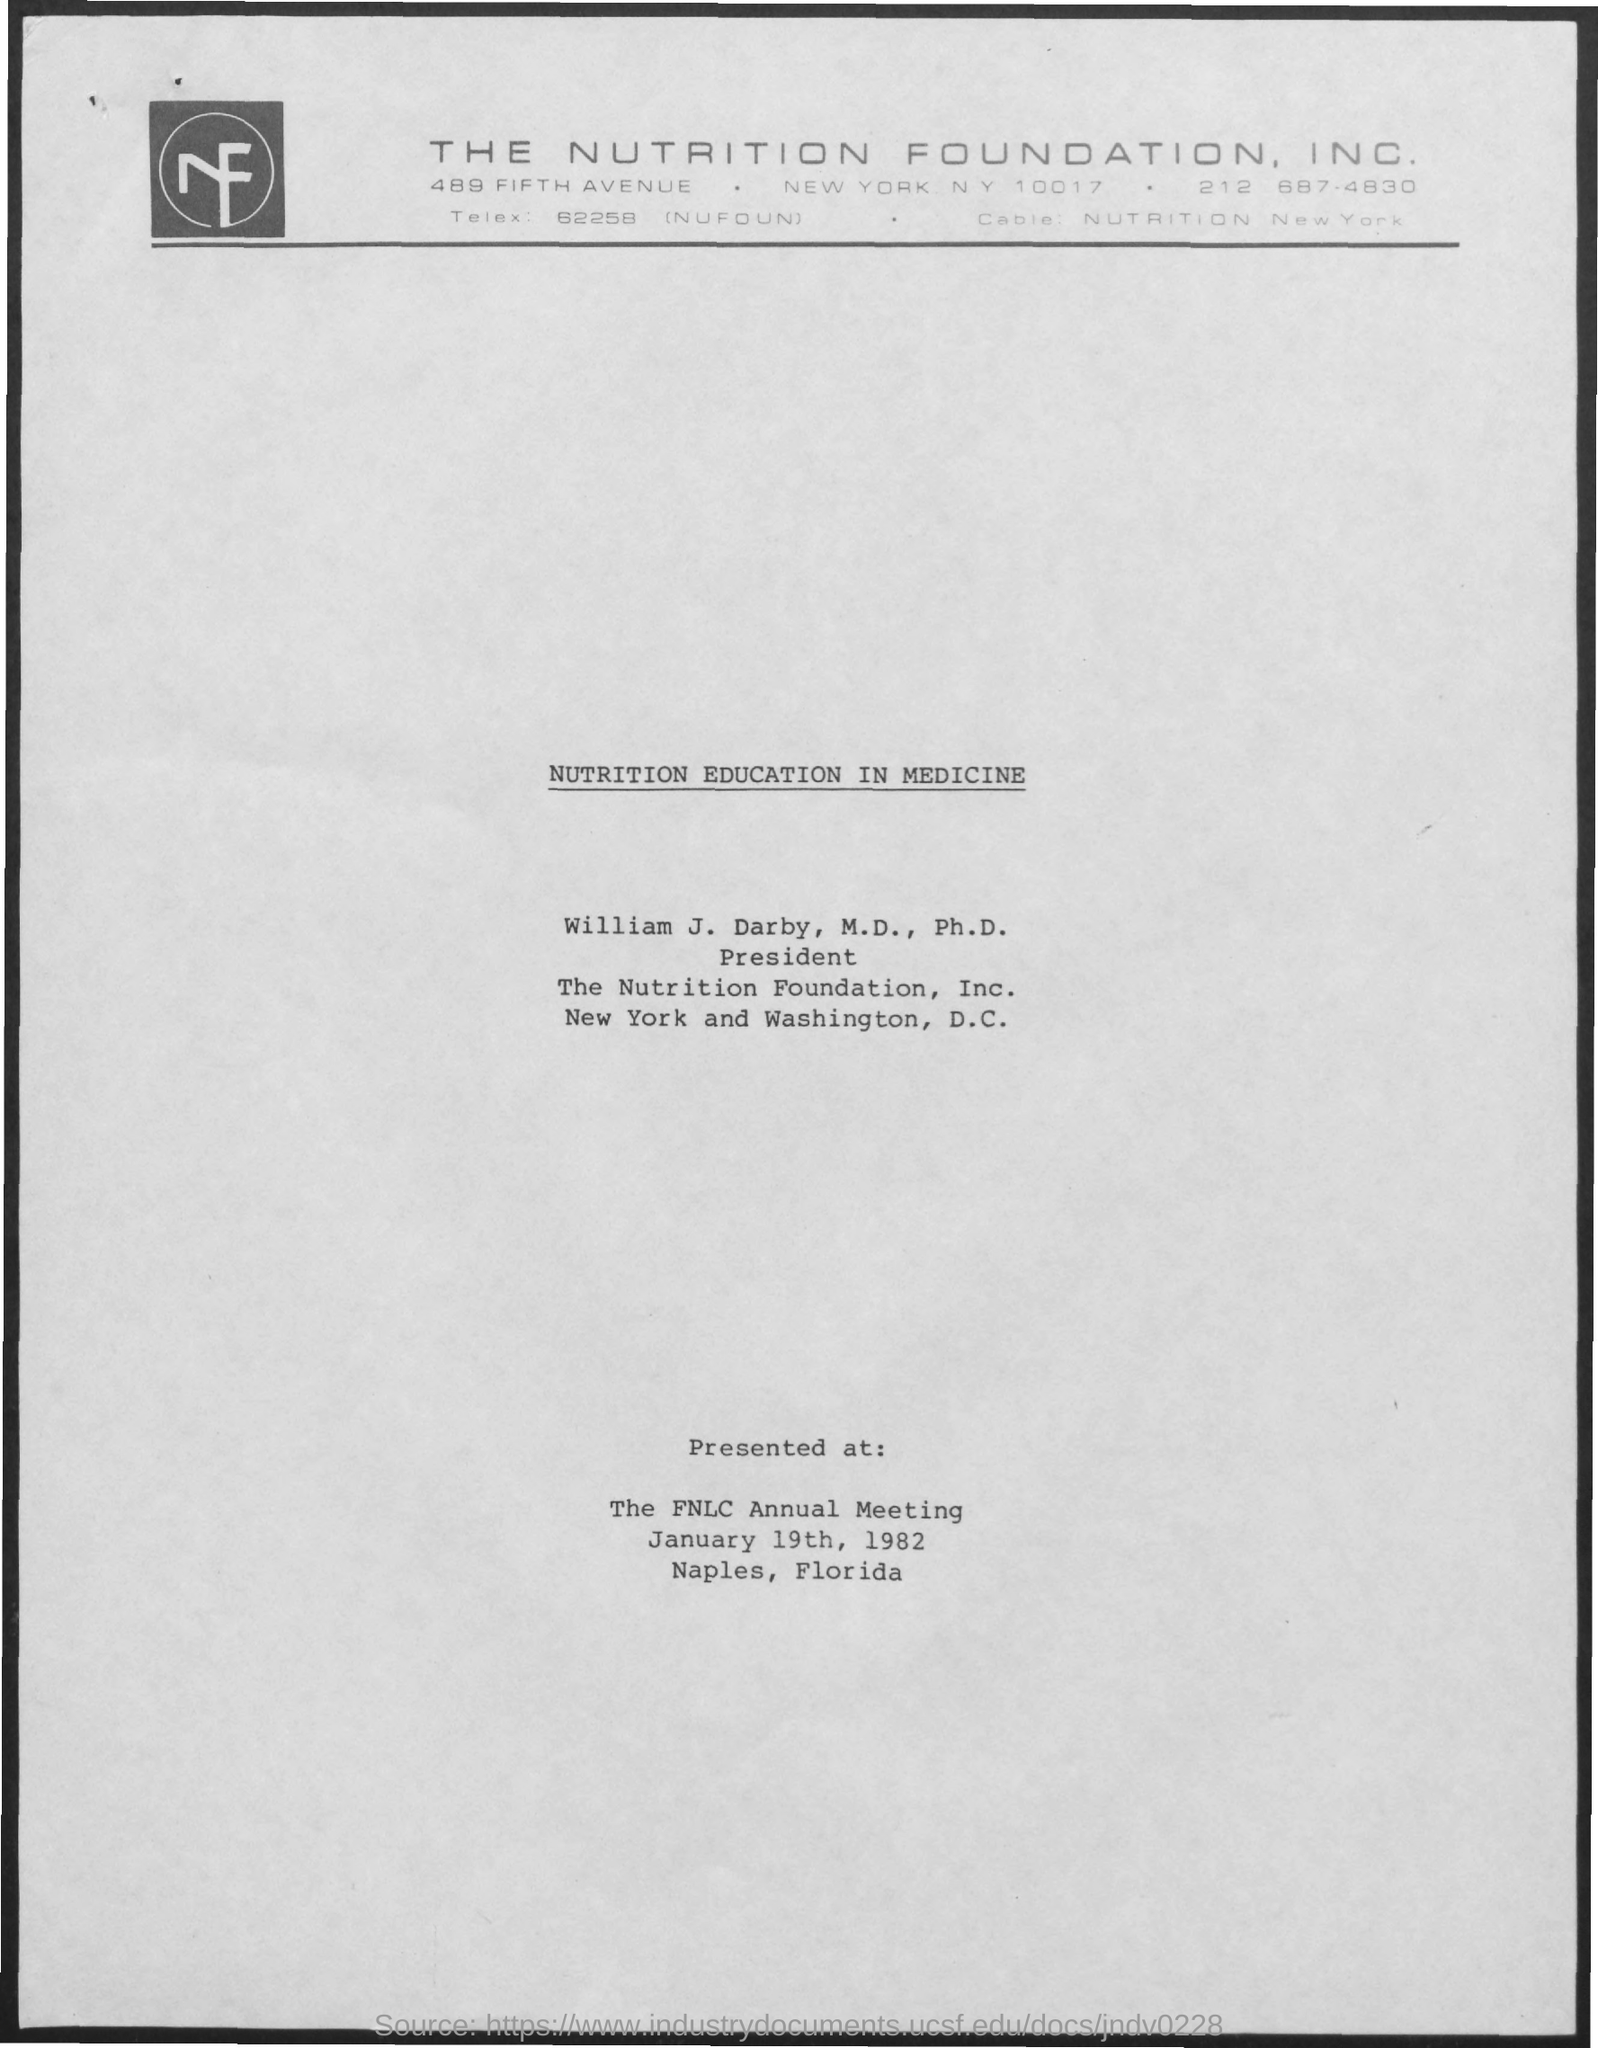Which foundation is mentioned?
Provide a short and direct response. THE NUTRITION FOUNDATION, INC. Who is the president of The Nutrition Foundation, Inc.?
Offer a very short reply. William J. Darby, M,D., Ph.D. Where was NUTRITION EDUCATION IN MEDICINE presented?
Ensure brevity in your answer.  The FNLC Annual Meeting. When was the meeting held?
Give a very brief answer. January 19th, 1982. Where was the meeting held?
Give a very brief answer. Naples, Florida. 